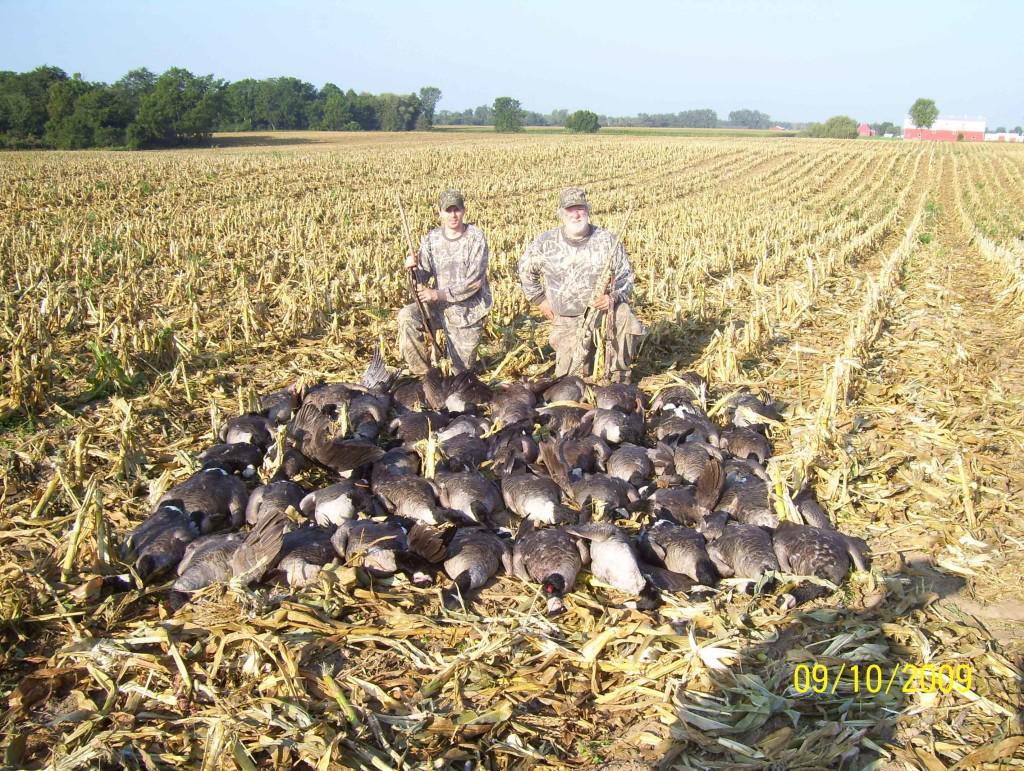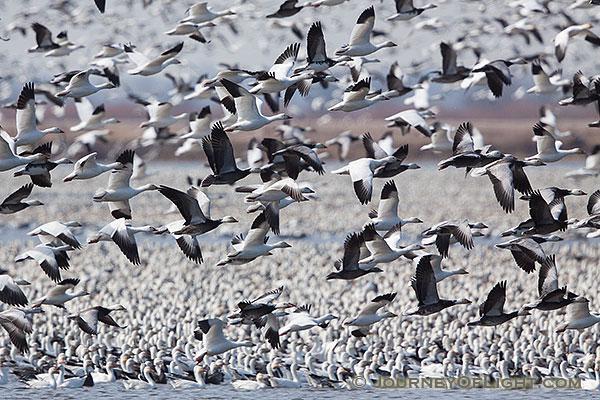The first image is the image on the left, the second image is the image on the right. Analyze the images presented: Is the assertion "There is water in the image on the left." valid? Answer yes or no. No. The first image is the image on the left, the second image is the image on the right. Assess this claim about the two images: "There is at least one person in one of the images.". Correct or not? Answer yes or no. Yes. The first image is the image on the left, the second image is the image on the right. For the images shown, is this caption "In one image, white ducks and geese are congregated on a green grassy field." true? Answer yes or no. No. The first image is the image on the left, the second image is the image on the right. For the images shown, is this caption "In at least one image, there are multiple birds in flight" true? Answer yes or no. Yes. 